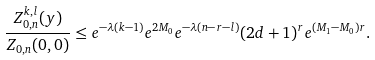<formula> <loc_0><loc_0><loc_500><loc_500>\frac { Z _ { 0 , n } ^ { k , l } ( y ) } { Z _ { 0 , n } ( 0 , 0 ) } \leq e ^ { - \lambda ( k - 1 ) } e ^ { 2 M _ { 0 } } e ^ { - \lambda ( n - r - l ) } ( 2 d + 1 ) ^ { r } e ^ { ( M _ { 1 } - M _ { 0 } ) r } .</formula> 